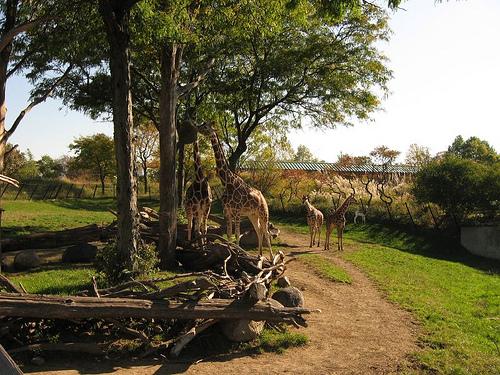How many tree trunks are visible?
Keep it brief. 3. Is there a building in this picture?
Short answer required. Yes. Are the animals at the left in the picture in the sun or shade?
Write a very short answer. Shade. 